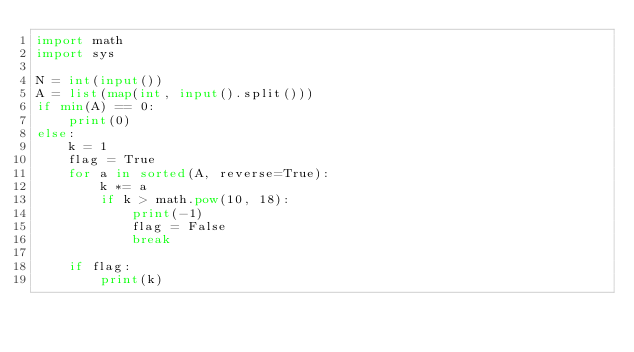Convert code to text. <code><loc_0><loc_0><loc_500><loc_500><_Python_>import math
import sys

N = int(input())
A = list(map(int, input().split()))
if min(A) == 0:
    print(0)
else:
    k = 1
    flag = True
    for a in sorted(A, reverse=True):
        k *= a
        if k > math.pow(10, 18):
            print(-1)
            flag = False
            break

    if flag:
        print(k)

 </code> 